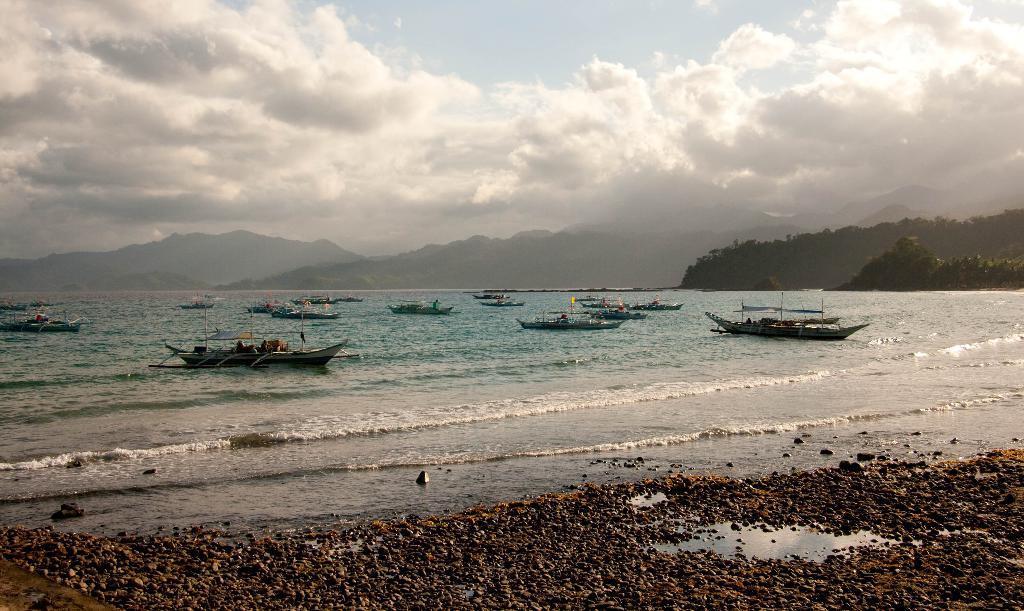In one or two sentences, can you explain what this image depicts? In this image in the center there are boats sailing on water. On the right side there are trees. In the background there are mountains and the sky is cloudy. 